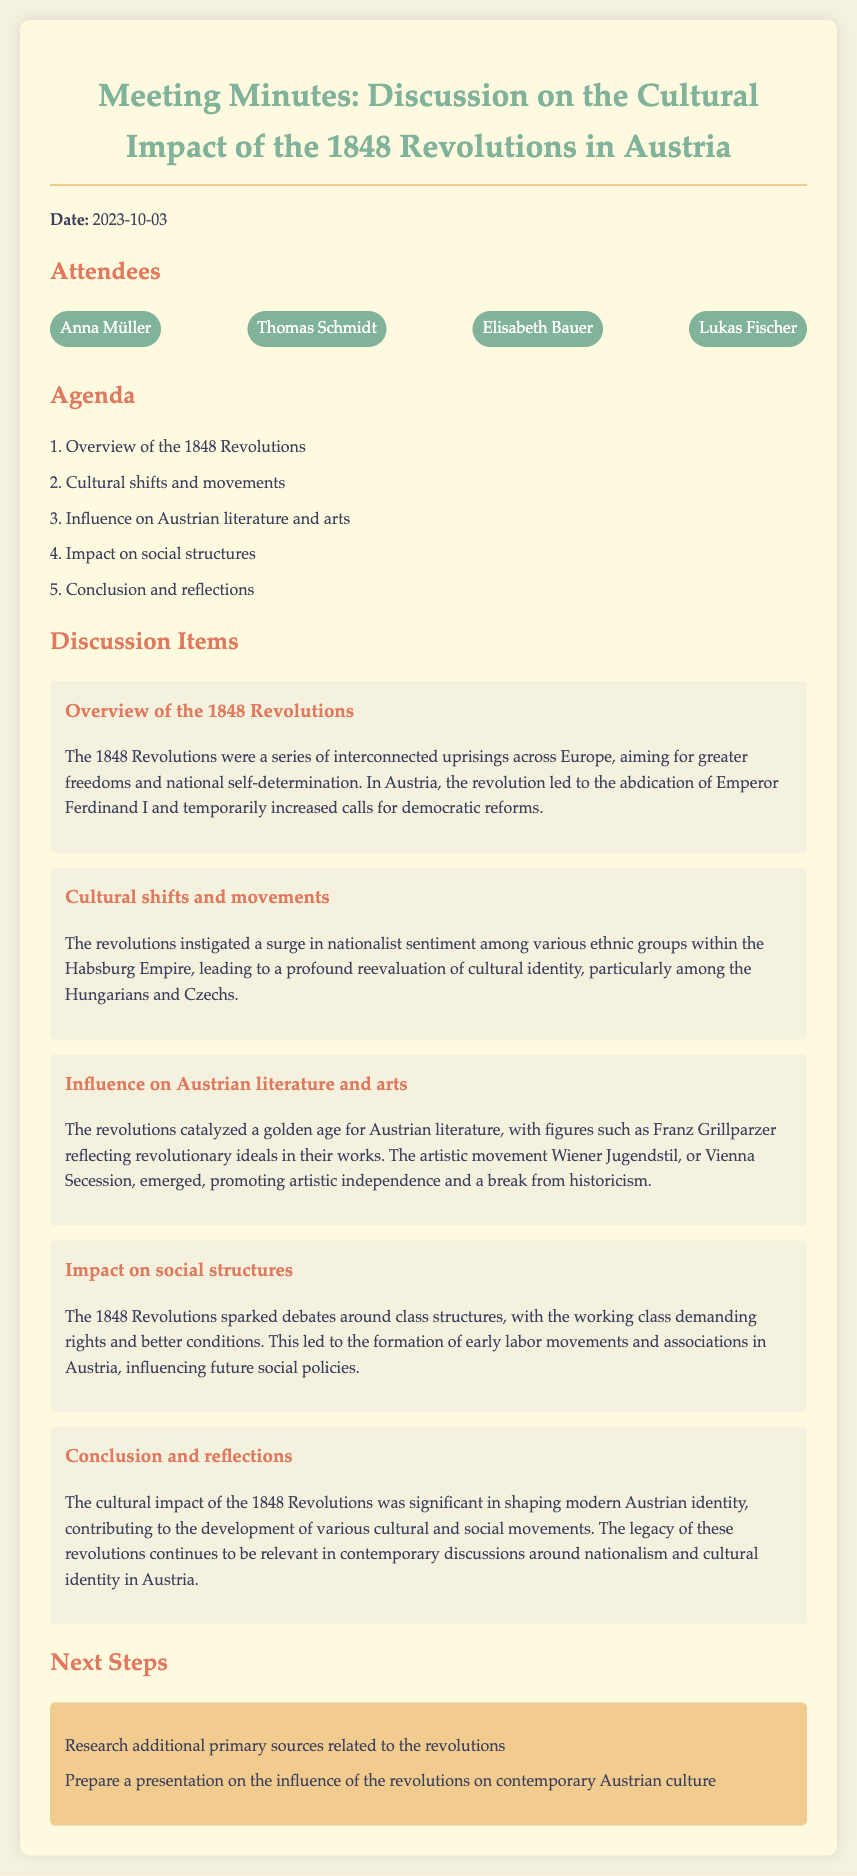what date was the meeting held? The document states that the meeting took place on October 3, 2023.
Answer: October 3, 2023 who were the attendees at the meeting? The attendees listed in the document are Anna Müller, Thomas Schmidt, Elisabeth Bauer, and Lukas Fischer.
Answer: Anna Müller, Thomas Schmidt, Elisabeth Bauer, Lukas Fischer what was one of the cultural shifts discussed? The discussion item mentions a surge in nationalist sentiment among various ethnic groups.
Answer: Nationalist sentiment which literary figure was mentioned in relation to the influence on Austrian literature? Franz Grillparzer is highlighted as a key figure reflecting revolutionary ideals in his works.
Answer: Franz Grillparzer how did the 1848 Revolutions impact social structures? The document notes that the revolutions sparked debates around class structures and led to the formation of early labor movements.
Answer: Early labor movements what is one of the next steps outlined in the meeting? One of the action items is to research additional primary sources related to the revolutions.
Answer: Research additional primary sources what was the impact of the revolutions on contemporary discussions? The document mentions that the legacy continues to be relevant in discussions around nationalism and cultural identity.
Answer: Nationalism and cultural identity 